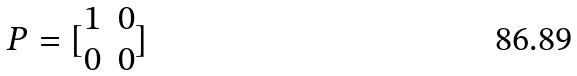<formula> <loc_0><loc_0><loc_500><loc_500>P = [ \begin{matrix} 1 & 0 \\ 0 & 0 \end{matrix} ]</formula> 